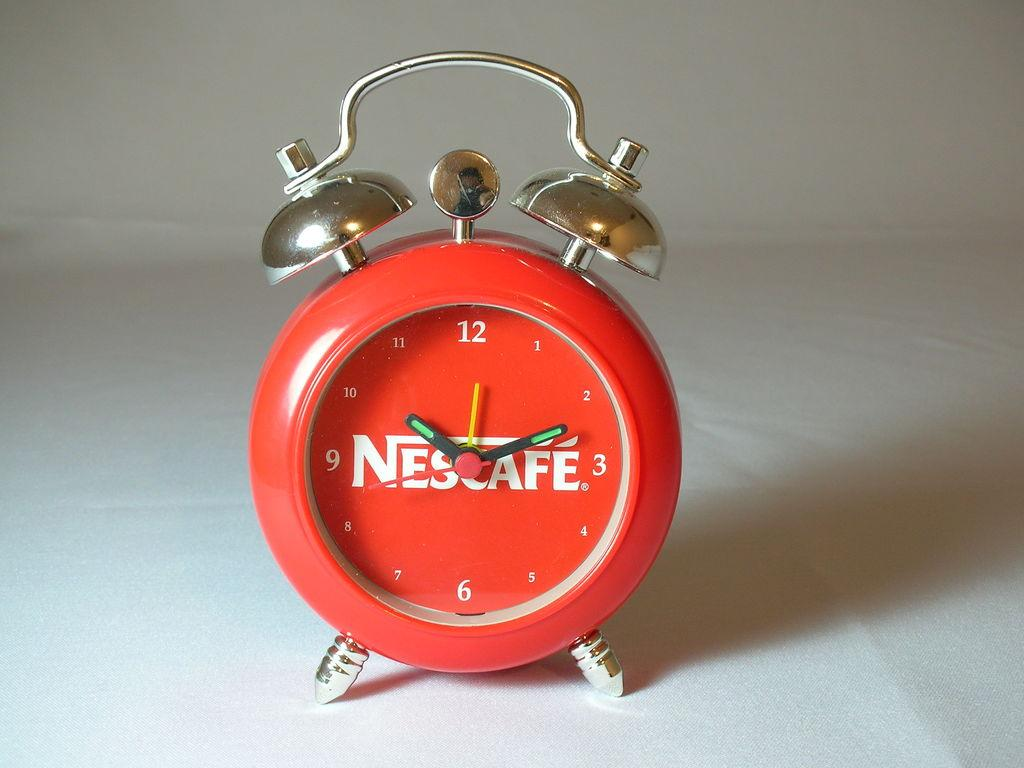<image>
Create a compact narrative representing the image presented. A red alarm clock with the Nescafe coffee logo on it. 